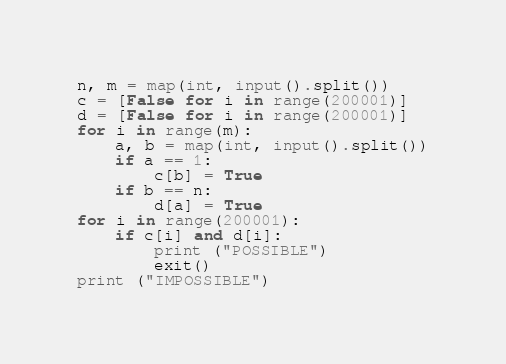<code> <loc_0><loc_0><loc_500><loc_500><_Python_>n, m = map(int, input().split())
c = [False for i in range(200001)]
d = [False for i in range(200001)]
for i in range(m):
	a, b = map(int, input().split())
	if a == 1:
		c[b] = True
	if b == n:
		d[a] = True
for i in range(200001):
	if c[i] and d[i]:
		print ("POSSIBLE")
		exit()
print ("IMPOSSIBLE")</code> 